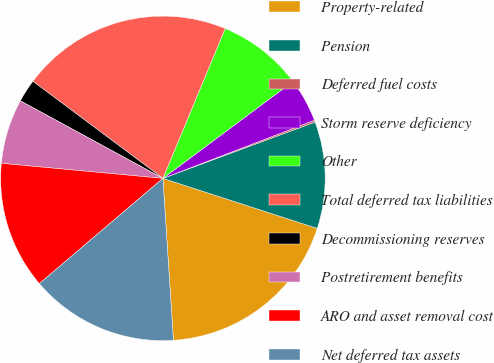<chart> <loc_0><loc_0><loc_500><loc_500><pie_chart><fcel>Property-related<fcel>Pension<fcel>Deferred fuel costs<fcel>Storm reserve deficiency<fcel>Other<fcel>Total deferred tax liabilities<fcel>Decommissioning reserves<fcel>Postretirement benefits<fcel>ARO and asset removal cost<fcel>Net deferred tax assets<nl><fcel>18.98%<fcel>10.63%<fcel>0.19%<fcel>4.36%<fcel>8.54%<fcel>21.06%<fcel>2.28%<fcel>6.45%<fcel>12.71%<fcel>14.8%<nl></chart> 